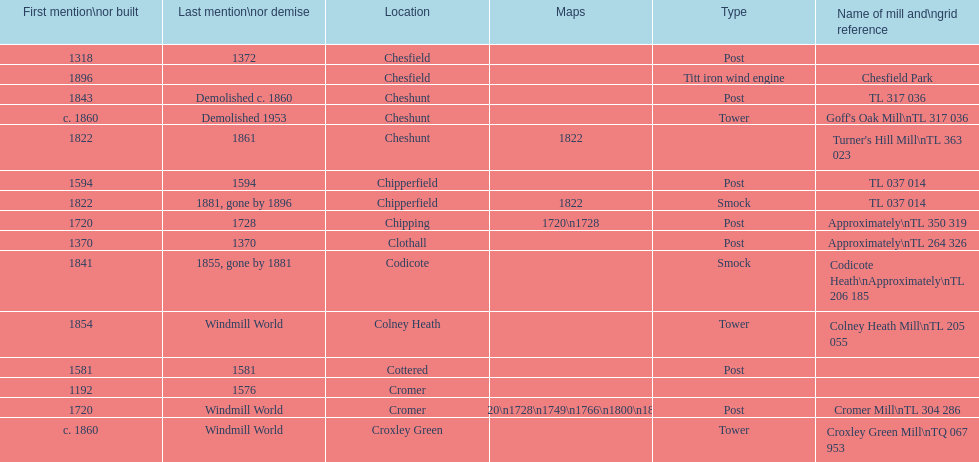How many locations have no photograph? 14. 